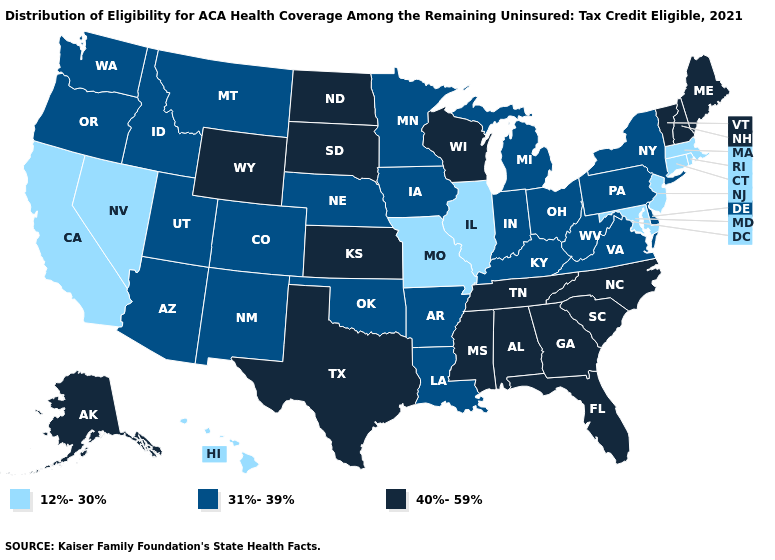Name the states that have a value in the range 40%-59%?
Give a very brief answer. Alabama, Alaska, Florida, Georgia, Kansas, Maine, Mississippi, New Hampshire, North Carolina, North Dakota, South Carolina, South Dakota, Tennessee, Texas, Vermont, Wisconsin, Wyoming. What is the lowest value in states that border Minnesota?
Keep it brief. 31%-39%. Does New Jersey have the highest value in the Northeast?
Write a very short answer. No. What is the value of New Mexico?
Write a very short answer. 31%-39%. What is the value of Pennsylvania?
Be succinct. 31%-39%. What is the value of Alabama?
Be succinct. 40%-59%. Does the first symbol in the legend represent the smallest category?
Quick response, please. Yes. What is the value of Wisconsin?
Write a very short answer. 40%-59%. Does the map have missing data?
Answer briefly. No. What is the lowest value in states that border New Hampshire?
Concise answer only. 12%-30%. Does Utah have the highest value in the USA?
Write a very short answer. No. What is the lowest value in the USA?
Keep it brief. 12%-30%. What is the value of Nevada?
Answer briefly. 12%-30%. What is the value of Virginia?
Be succinct. 31%-39%. Does North Dakota have a higher value than Louisiana?
Answer briefly. Yes. 